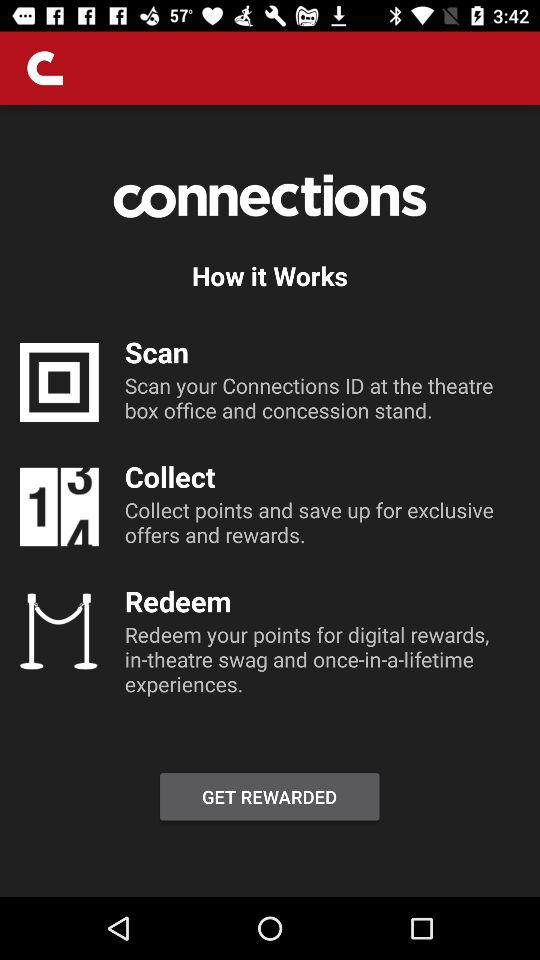What is the application name? The application name is "connections". 